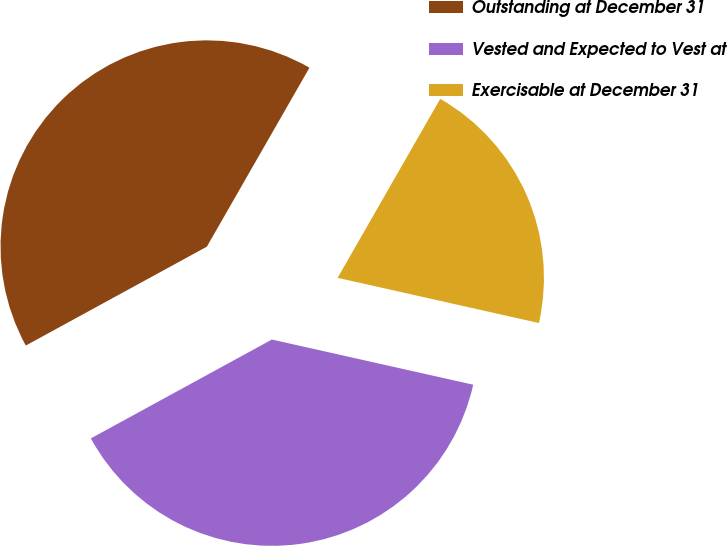<chart> <loc_0><loc_0><loc_500><loc_500><pie_chart><fcel>Outstanding at December 31<fcel>Vested and Expected to Vest at<fcel>Exercisable at December 31<nl><fcel>41.24%<fcel>38.53%<fcel>20.23%<nl></chart> 